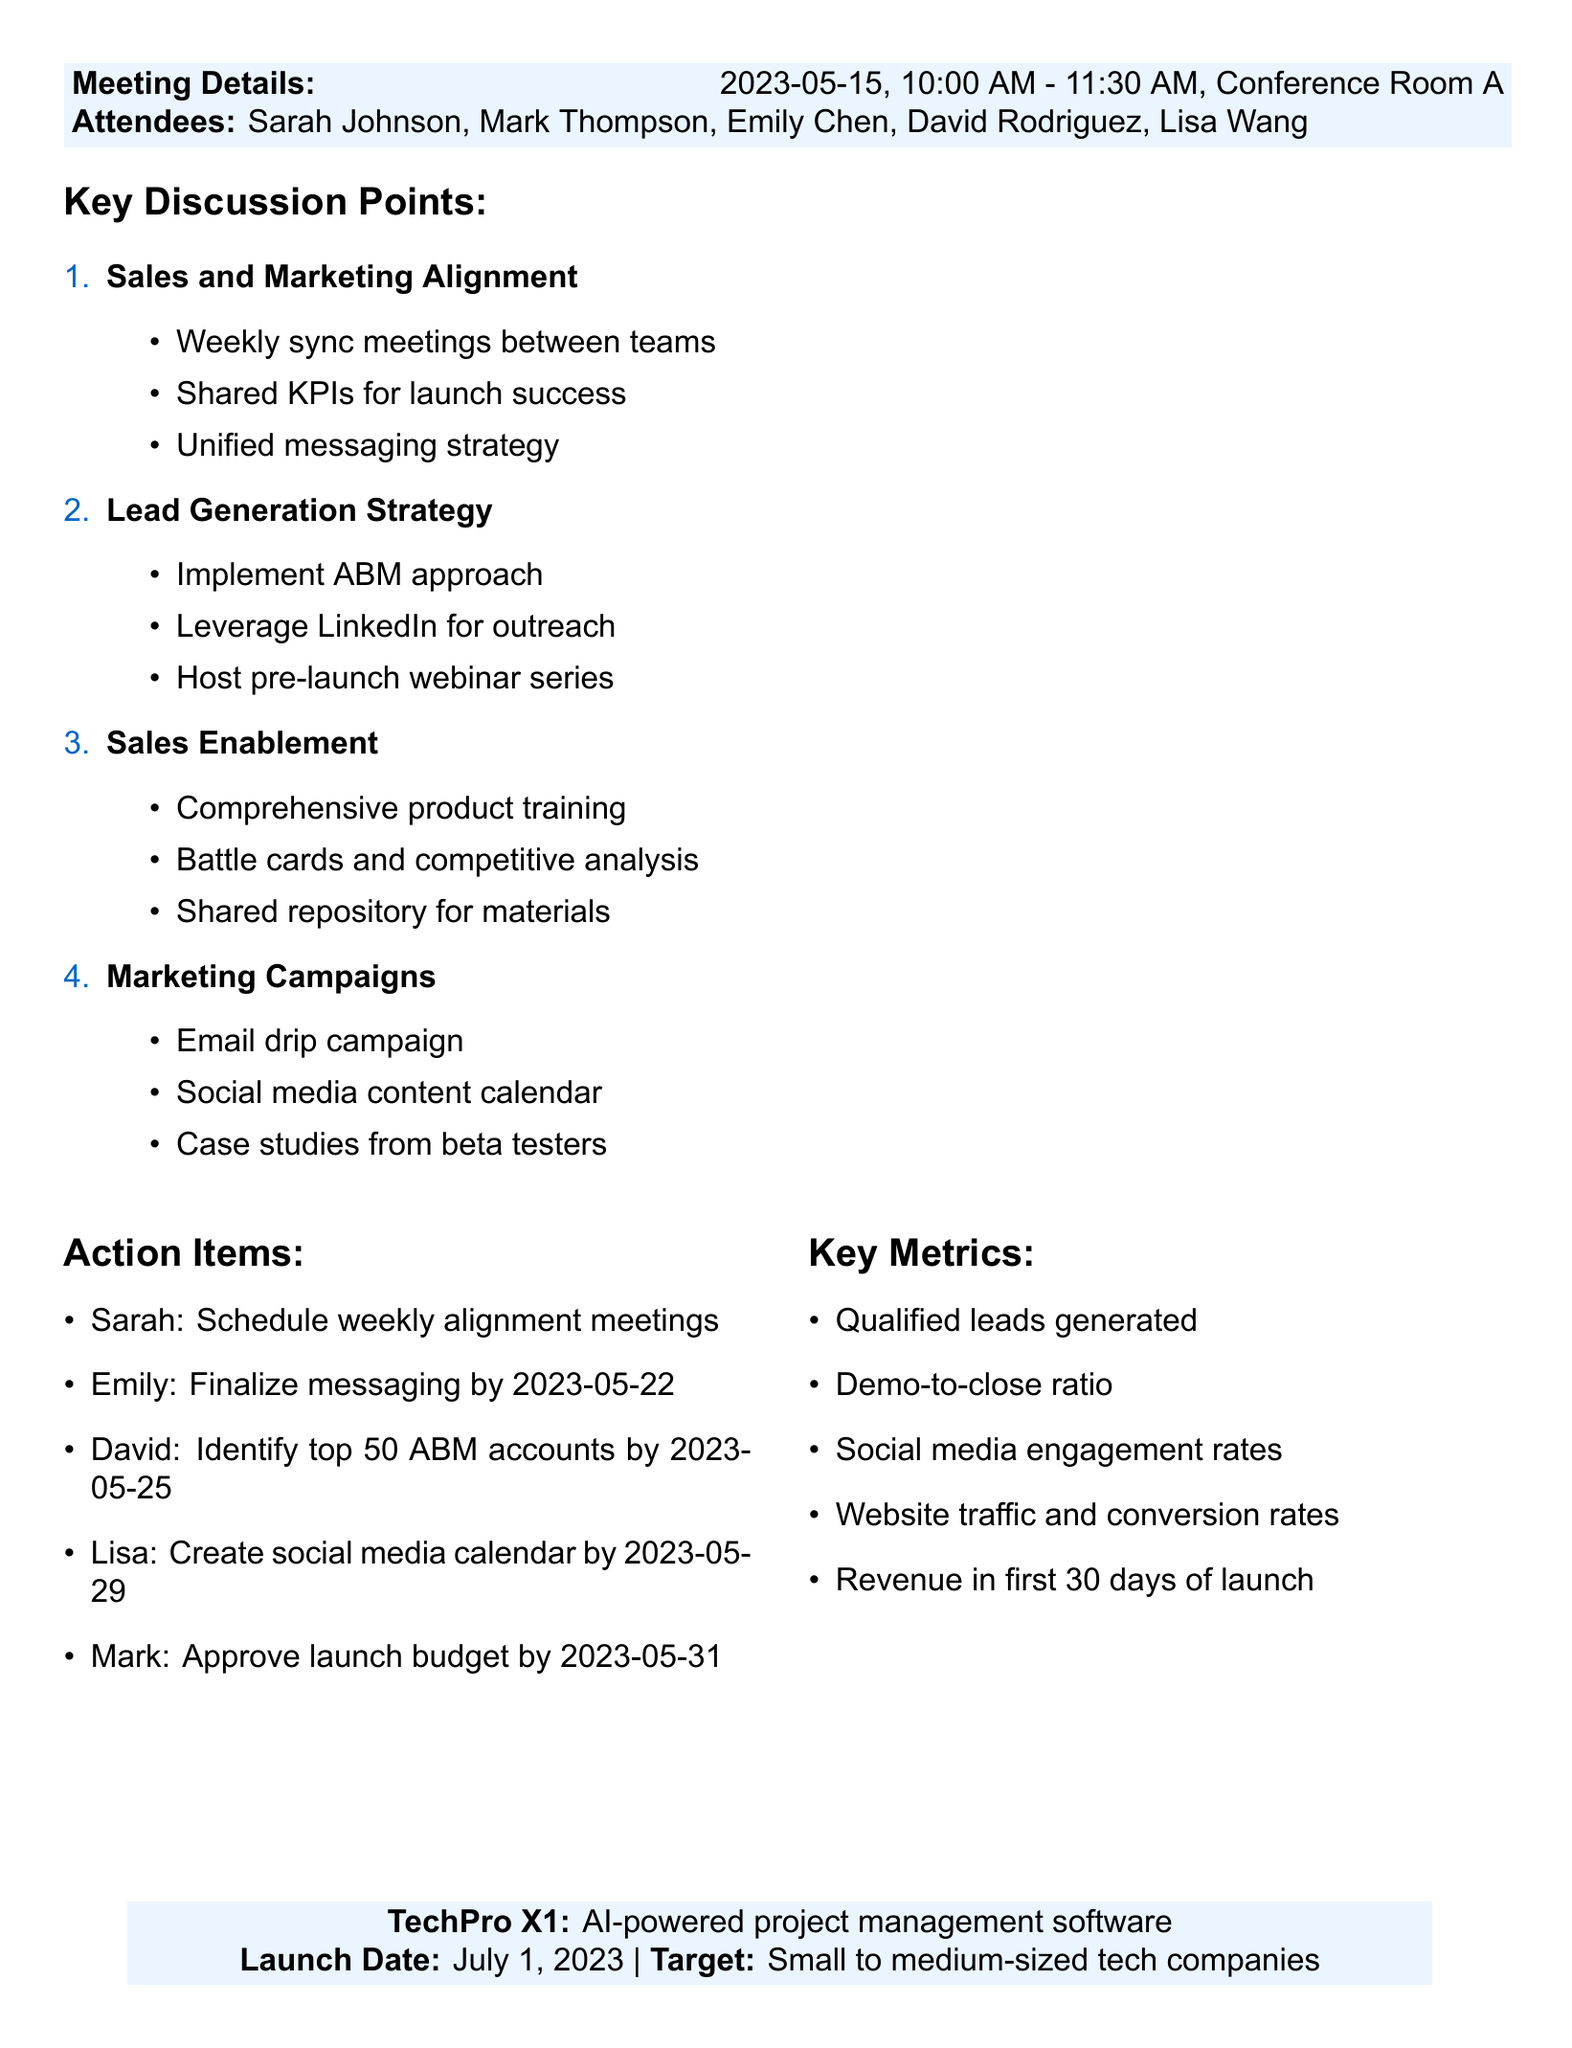What is the date of the meeting? The meeting date is explicitly stated in the document.
Answer: 2023-05-15 Who is the CMO present at the meeting? The document lists all attendees, including their roles.
Answer: Mark Thompson What is the name of the product being launched? The product information includes its name.
Answer: TechPro X1 When is the launch date of the product? The specific launch date is mentioned in the product information section.
Answer: 2023-07-01 What is one of the key metrics mentioned for the launch? The document lists key metrics that are important for evaluating the success of the launch.
Answer: Number of qualified leads generated What action item is assigned to Emily? The action items section specifies tasks designated to attendees.
Answer: Finalize product messaging and value proposition by 2023-05-22 How many sales and marketing alignment meetings are proposed? The discussion points indicate the frequency of meetings suggested.
Answer: Weekly What marketing strategy is suggested to generate leads? The lead generation strategy outlines specific approaches to attract potential customers.
Answer: Implement account-based marketing approach What type of software is TechPro X1? The product information provides the type of product being launched.
Answer: AI-powered project management software 